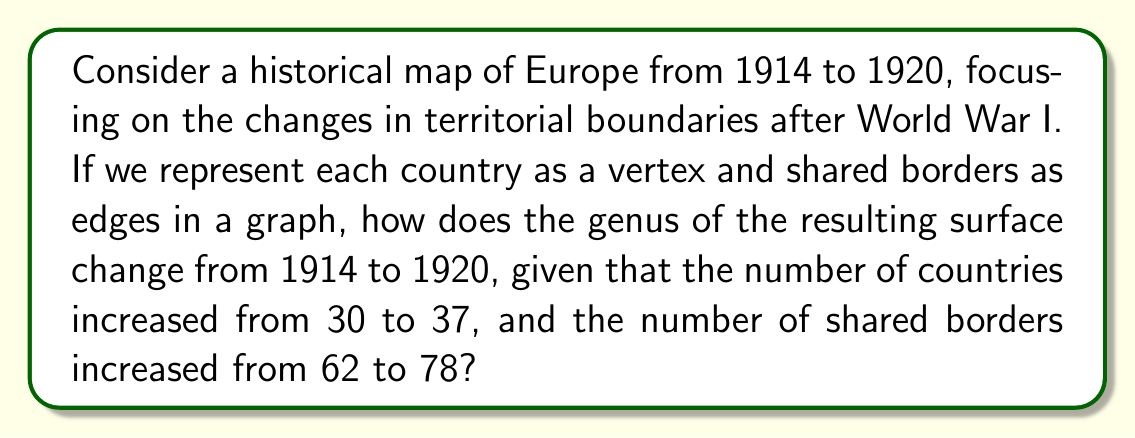Give your solution to this math problem. To solve this problem, we'll use the Euler characteristic formula for planar graphs and its relationship to the genus of a surface. This approach aligns with your background in history while exploring the topological aspects of changing territorial boundaries.

1. Euler characteristic formula: $\chi = V - E + F$
   Where $\chi$ is the Euler characteristic, $V$ is the number of vertices, $E$ is the number of edges, and $F$ is the number of faces.

2. For a planar graph (map on a sphere), $F = E - V + 2$

3. The relationship between Euler characteristic and genus: $\chi = 2 - 2g$
   Where $g$ is the genus of the surface.

Let's analyze the two scenarios:

1914:
$V_{1914} = 30$ (countries)
$E_{1914} = 62$ (shared borders)
$F_{1914} = E_{1914} - V_{1914} + 2 = 62 - 30 + 2 = 34$

$\chi_{1914} = V_{1914} - E_{1914} + F_{1914} = 30 - 62 + 34 = 2$

1920:
$V_{1920} = 37$ (countries)
$E_{1920} = 78$ (shared borders)
$F_{1920} = E_{1920} - V_{1920} + 2 = 78 - 37 + 2 = 43$

$\chi_{1920} = V_{1920} - E_{1920} + F_{1920} = 37 - 78 + 43 = 2$

Now, we can calculate the genus for both years:

$\chi = 2 - 2g$
$2 = 2 - 2g$
$2g = 0$
$g = 0$

The genus remains 0 for both 1914 and 1920, indicating that the surface is topologically equivalent to a sphere in both cases.
Answer: The genus of the resulting surface does not change from 1914 to 1920; it remains 0 in both cases. 